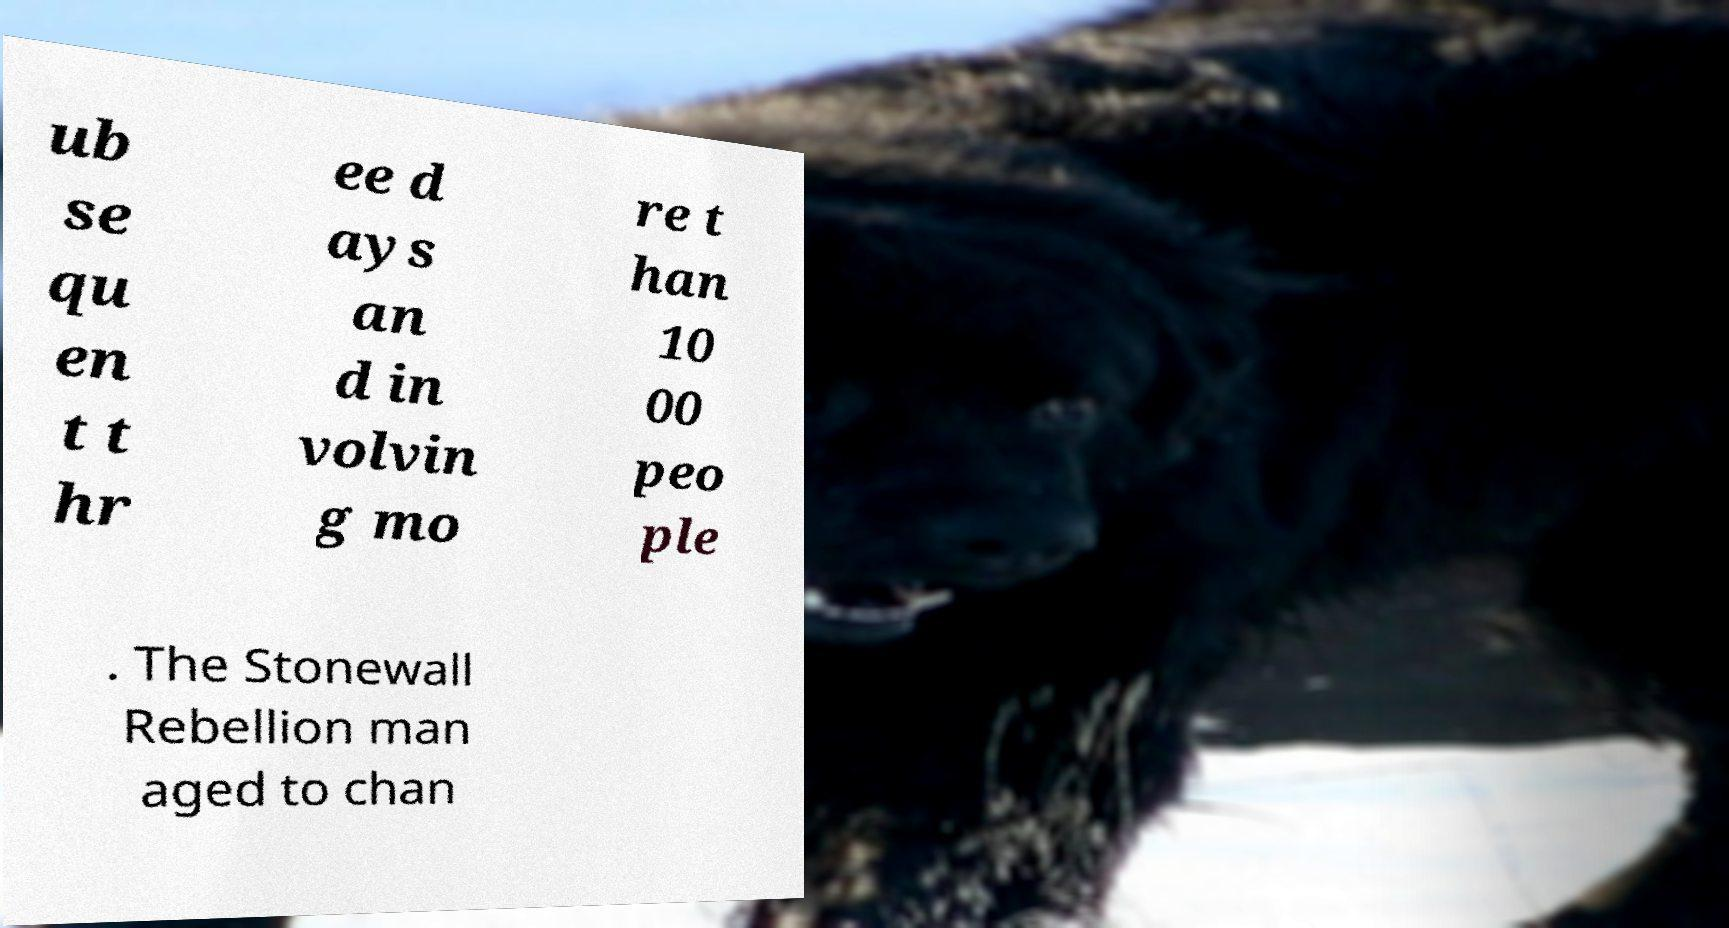I need the written content from this picture converted into text. Can you do that? ub se qu en t t hr ee d ays an d in volvin g mo re t han 10 00 peo ple . The Stonewall Rebellion man aged to chan 